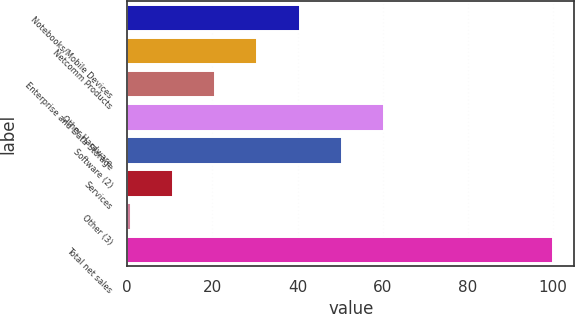Convert chart to OTSL. <chart><loc_0><loc_0><loc_500><loc_500><bar_chart><fcel>Notebooks/Mobile Devices<fcel>Netcomm Products<fcel>Enterprise and Data Storage<fcel>Other Hardware<fcel>Software (2)<fcel>Services<fcel>Other (3)<fcel>Total net sales<nl><fcel>40.48<fcel>30.56<fcel>20.64<fcel>60.32<fcel>50.4<fcel>10.72<fcel>0.8<fcel>100<nl></chart> 